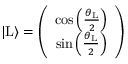Convert formula to latex. <formula><loc_0><loc_0><loc_500><loc_500>\begin{array} { r } { | L \rangle = \left ( \begin{array} { c c } { \cos \left ( \frac { \theta _ { L } } { 2 } \right ) } \\ { \sin \left ( \frac { \theta _ { L } } { 2 } \right ) } \end{array} \right ) } \end{array}</formula> 